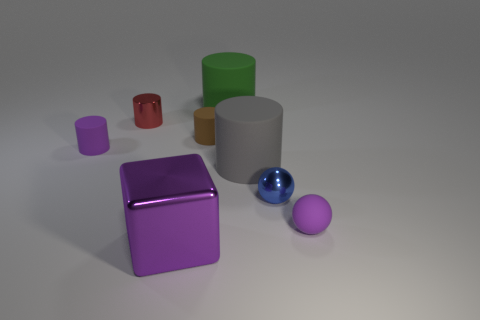Subtract all red metallic cylinders. How many cylinders are left? 4 Subtract 1 cylinders. How many cylinders are left? 4 Subtract all green cylinders. How many cylinders are left? 4 Add 1 tiny yellow blocks. How many objects exist? 9 Subtract all small metallic objects. Subtract all tiny balls. How many objects are left? 4 Add 8 red cylinders. How many red cylinders are left? 9 Add 3 tiny purple rubber things. How many tiny purple rubber things exist? 5 Subtract 0 blue cubes. How many objects are left? 8 Subtract all balls. How many objects are left? 6 Subtract all green spheres. Subtract all gray blocks. How many spheres are left? 2 